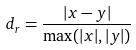Convert formula to latex. <formula><loc_0><loc_0><loc_500><loc_500>d _ { r } = \frac { | x - y | } { \max ( | x | , | y | ) }</formula> 